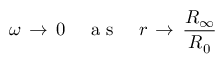<formula> <loc_0><loc_0><loc_500><loc_500>\omega \, \to \, 0 \quad a s \quad r \, \to \, \frac { R _ { \infty } } { R _ { 0 } }</formula> 